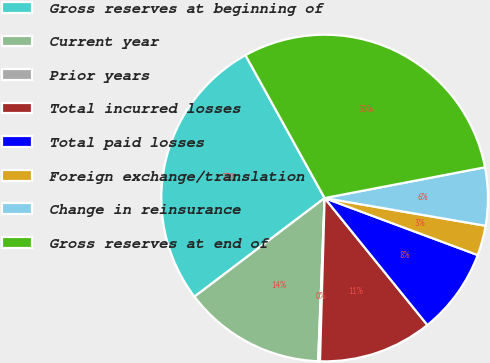Convert chart. <chart><loc_0><loc_0><loc_500><loc_500><pie_chart><fcel>Gross reserves at beginning of<fcel>Current year<fcel>Prior years<fcel>Total incurred losses<fcel>Total paid losses<fcel>Foreign exchange/translation<fcel>Change in reinsurance<fcel>Gross reserves at end of<nl><fcel>27.27%<fcel>14.05%<fcel>0.18%<fcel>11.28%<fcel>8.5%<fcel>2.96%<fcel>5.73%<fcel>30.04%<nl></chart> 